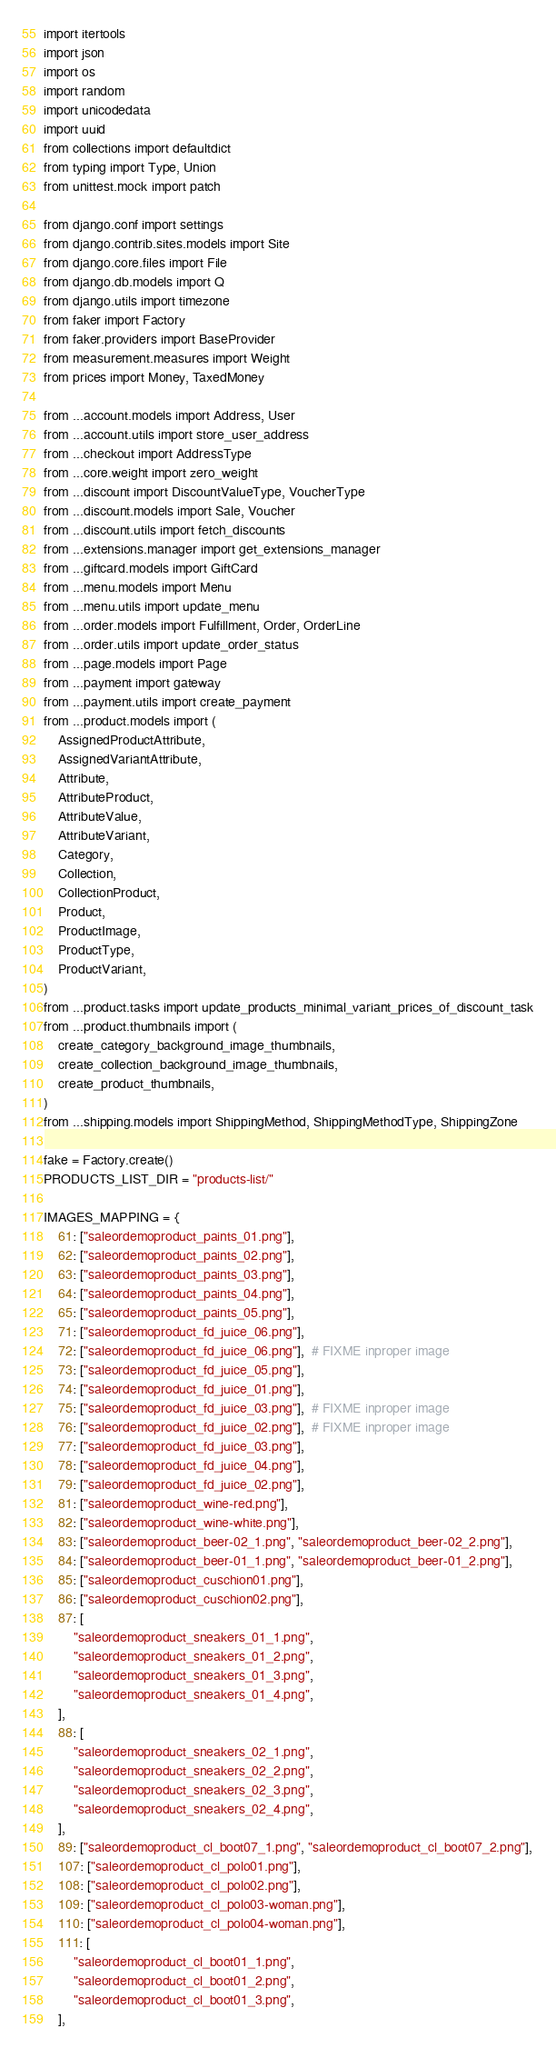<code> <loc_0><loc_0><loc_500><loc_500><_Python_>import itertools
import json
import os
import random
import unicodedata
import uuid
from collections import defaultdict
from typing import Type, Union
from unittest.mock import patch

from django.conf import settings
from django.contrib.sites.models import Site
from django.core.files import File
from django.db.models import Q
from django.utils import timezone
from faker import Factory
from faker.providers import BaseProvider
from measurement.measures import Weight
from prices import Money, TaxedMoney

from ...account.models import Address, User
from ...account.utils import store_user_address
from ...checkout import AddressType
from ...core.weight import zero_weight
from ...discount import DiscountValueType, VoucherType
from ...discount.models import Sale, Voucher
from ...discount.utils import fetch_discounts
from ...extensions.manager import get_extensions_manager
from ...giftcard.models import GiftCard
from ...menu.models import Menu
from ...menu.utils import update_menu
from ...order.models import Fulfillment, Order, OrderLine
from ...order.utils import update_order_status
from ...page.models import Page
from ...payment import gateway
from ...payment.utils import create_payment
from ...product.models import (
    AssignedProductAttribute,
    AssignedVariantAttribute,
    Attribute,
    AttributeProduct,
    AttributeValue,
    AttributeVariant,
    Category,
    Collection,
    CollectionProduct,
    Product,
    ProductImage,
    ProductType,
    ProductVariant,
)
from ...product.tasks import update_products_minimal_variant_prices_of_discount_task
from ...product.thumbnails import (
    create_category_background_image_thumbnails,
    create_collection_background_image_thumbnails,
    create_product_thumbnails,
)
from ...shipping.models import ShippingMethod, ShippingMethodType, ShippingZone

fake = Factory.create()
PRODUCTS_LIST_DIR = "products-list/"

IMAGES_MAPPING = {
    61: ["saleordemoproduct_paints_01.png"],
    62: ["saleordemoproduct_paints_02.png"],
    63: ["saleordemoproduct_paints_03.png"],
    64: ["saleordemoproduct_paints_04.png"],
    65: ["saleordemoproduct_paints_05.png"],
    71: ["saleordemoproduct_fd_juice_06.png"],
    72: ["saleordemoproduct_fd_juice_06.png"],  # FIXME inproper image
    73: ["saleordemoproduct_fd_juice_05.png"],
    74: ["saleordemoproduct_fd_juice_01.png"],
    75: ["saleordemoproduct_fd_juice_03.png"],  # FIXME inproper image
    76: ["saleordemoproduct_fd_juice_02.png"],  # FIXME inproper image
    77: ["saleordemoproduct_fd_juice_03.png"],
    78: ["saleordemoproduct_fd_juice_04.png"],
    79: ["saleordemoproduct_fd_juice_02.png"],
    81: ["saleordemoproduct_wine-red.png"],
    82: ["saleordemoproduct_wine-white.png"],
    83: ["saleordemoproduct_beer-02_1.png", "saleordemoproduct_beer-02_2.png"],
    84: ["saleordemoproduct_beer-01_1.png", "saleordemoproduct_beer-01_2.png"],
    85: ["saleordemoproduct_cuschion01.png"],
    86: ["saleordemoproduct_cuschion02.png"],
    87: [
        "saleordemoproduct_sneakers_01_1.png",
        "saleordemoproduct_sneakers_01_2.png",
        "saleordemoproduct_sneakers_01_3.png",
        "saleordemoproduct_sneakers_01_4.png",
    ],
    88: [
        "saleordemoproduct_sneakers_02_1.png",
        "saleordemoproduct_sneakers_02_2.png",
        "saleordemoproduct_sneakers_02_3.png",
        "saleordemoproduct_sneakers_02_4.png",
    ],
    89: ["saleordemoproduct_cl_boot07_1.png", "saleordemoproduct_cl_boot07_2.png"],
    107: ["saleordemoproduct_cl_polo01.png"],
    108: ["saleordemoproduct_cl_polo02.png"],
    109: ["saleordemoproduct_cl_polo03-woman.png"],
    110: ["saleordemoproduct_cl_polo04-woman.png"],
    111: [
        "saleordemoproduct_cl_boot01_1.png",
        "saleordemoproduct_cl_boot01_2.png",
        "saleordemoproduct_cl_boot01_3.png",
    ],</code> 